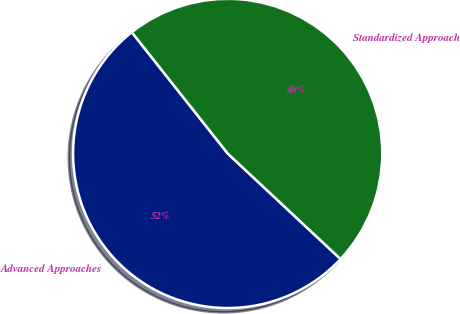Convert chart. <chart><loc_0><loc_0><loc_500><loc_500><pie_chart><fcel>Advanced Approaches<fcel>Standardized Approach<nl><fcel>52.38%<fcel>47.62%<nl></chart> 